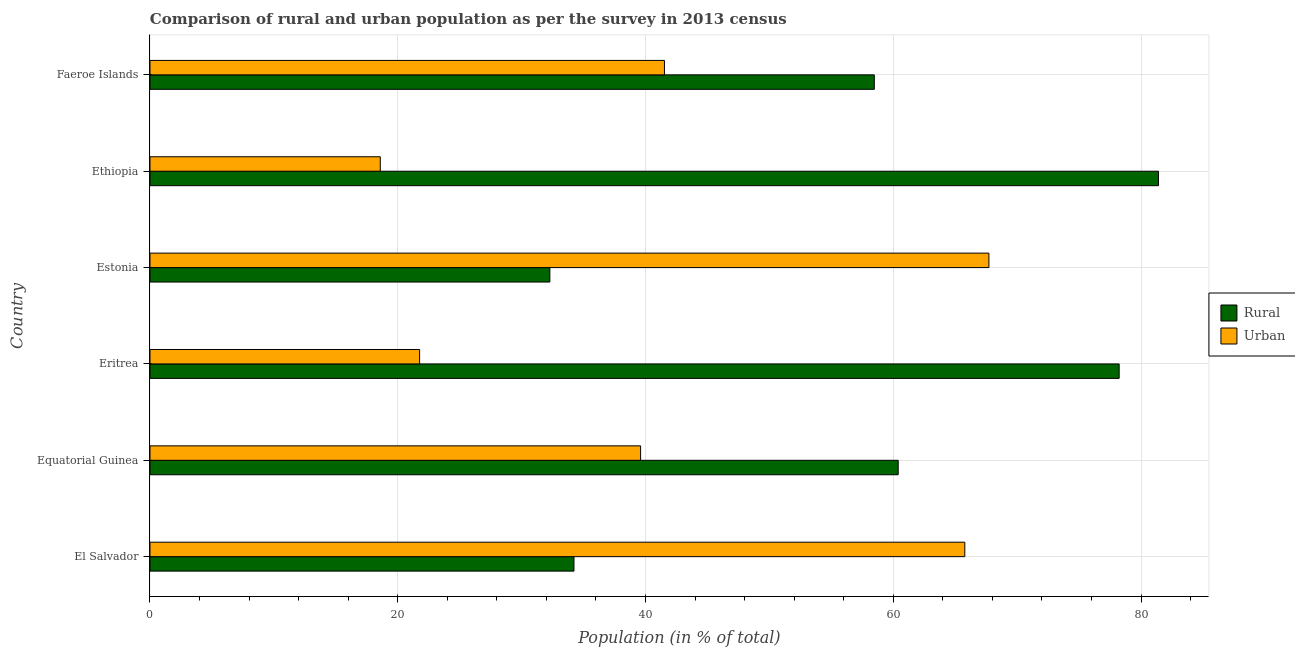How many different coloured bars are there?
Your answer should be compact. 2. How many bars are there on the 3rd tick from the bottom?
Offer a terse response. 2. What is the label of the 4th group of bars from the top?
Your answer should be very brief. Eritrea. In how many cases, is the number of bars for a given country not equal to the number of legend labels?
Provide a succinct answer. 0. What is the urban population in Faeroe Islands?
Offer a terse response. 41.53. Across all countries, what is the maximum urban population?
Your response must be concise. 67.72. Across all countries, what is the minimum urban population?
Provide a short and direct response. 18.59. In which country was the urban population maximum?
Give a very brief answer. Estonia. In which country was the rural population minimum?
Ensure brevity in your answer.  Estonia. What is the total urban population in the graph?
Ensure brevity in your answer.  254.98. What is the difference between the urban population in Ethiopia and that in Faeroe Islands?
Provide a succinct answer. -22.94. What is the difference between the rural population in Equatorial Guinea and the urban population in Ethiopia?
Provide a succinct answer. 41.81. What is the average rural population per country?
Provide a short and direct response. 57.5. What is the difference between the urban population and rural population in Equatorial Guinea?
Make the answer very short. -20.79. What is the ratio of the urban population in Equatorial Guinea to that in Ethiopia?
Your answer should be compact. 2.13. Is the urban population in Equatorial Guinea less than that in Ethiopia?
Offer a terse response. No. What is the difference between the highest and the second highest urban population?
Offer a terse response. 1.95. What is the difference between the highest and the lowest rural population?
Provide a succinct answer. 49.13. Is the sum of the rural population in El Salvador and Estonia greater than the maximum urban population across all countries?
Your response must be concise. No. What does the 2nd bar from the top in Faeroe Islands represents?
Make the answer very short. Rural. What does the 1st bar from the bottom in Equatorial Guinea represents?
Give a very brief answer. Rural. How many bars are there?
Your response must be concise. 12. How many countries are there in the graph?
Make the answer very short. 6. Are the values on the major ticks of X-axis written in scientific E-notation?
Your response must be concise. No. Does the graph contain grids?
Keep it short and to the point. Yes. Where does the legend appear in the graph?
Ensure brevity in your answer.  Center right. How many legend labels are there?
Offer a terse response. 2. What is the title of the graph?
Make the answer very short. Comparison of rural and urban population as per the survey in 2013 census. What is the label or title of the X-axis?
Make the answer very short. Population (in % of total). What is the Population (in % of total) in Rural in El Salvador?
Ensure brevity in your answer.  34.23. What is the Population (in % of total) in Urban in El Salvador?
Your answer should be very brief. 65.78. What is the Population (in % of total) of Rural in Equatorial Guinea?
Your response must be concise. 60.4. What is the Population (in % of total) in Urban in Equatorial Guinea?
Provide a succinct answer. 39.6. What is the Population (in % of total) in Rural in Eritrea?
Your answer should be compact. 78.23. What is the Population (in % of total) of Urban in Eritrea?
Offer a very short reply. 21.77. What is the Population (in % of total) of Rural in Estonia?
Keep it short and to the point. 32.28. What is the Population (in % of total) in Urban in Estonia?
Give a very brief answer. 67.72. What is the Population (in % of total) in Rural in Ethiopia?
Give a very brief answer. 81.41. What is the Population (in % of total) in Urban in Ethiopia?
Provide a short and direct response. 18.59. What is the Population (in % of total) in Rural in Faeroe Islands?
Give a very brief answer. 58.47. What is the Population (in % of total) of Urban in Faeroe Islands?
Your answer should be compact. 41.53. Across all countries, what is the maximum Population (in % of total) of Rural?
Keep it short and to the point. 81.41. Across all countries, what is the maximum Population (in % of total) in Urban?
Provide a succinct answer. 67.72. Across all countries, what is the minimum Population (in % of total) of Rural?
Make the answer very short. 32.28. Across all countries, what is the minimum Population (in % of total) in Urban?
Make the answer very short. 18.59. What is the total Population (in % of total) in Rural in the graph?
Make the answer very short. 345.02. What is the total Population (in % of total) in Urban in the graph?
Ensure brevity in your answer.  254.98. What is the difference between the Population (in % of total) of Rural in El Salvador and that in Equatorial Guinea?
Offer a terse response. -26.17. What is the difference between the Population (in % of total) in Urban in El Salvador and that in Equatorial Guinea?
Keep it short and to the point. 26.17. What is the difference between the Population (in % of total) in Rural in El Salvador and that in Eritrea?
Provide a short and direct response. -44.01. What is the difference between the Population (in % of total) of Urban in El Salvador and that in Eritrea?
Make the answer very short. 44.01. What is the difference between the Population (in % of total) in Rural in El Salvador and that in Estonia?
Offer a terse response. 1.95. What is the difference between the Population (in % of total) in Urban in El Salvador and that in Estonia?
Give a very brief answer. -1.95. What is the difference between the Population (in % of total) of Rural in El Salvador and that in Ethiopia?
Provide a short and direct response. -47.19. What is the difference between the Population (in % of total) in Urban in El Salvador and that in Ethiopia?
Provide a short and direct response. 47.19. What is the difference between the Population (in % of total) of Rural in El Salvador and that in Faeroe Islands?
Your response must be concise. -24.25. What is the difference between the Population (in % of total) in Urban in El Salvador and that in Faeroe Islands?
Your answer should be very brief. 24.25. What is the difference between the Population (in % of total) in Rural in Equatorial Guinea and that in Eritrea?
Your answer should be compact. -17.84. What is the difference between the Population (in % of total) of Urban in Equatorial Guinea and that in Eritrea?
Provide a succinct answer. 17.84. What is the difference between the Population (in % of total) in Rural in Equatorial Guinea and that in Estonia?
Provide a succinct answer. 28.12. What is the difference between the Population (in % of total) of Urban in Equatorial Guinea and that in Estonia?
Your answer should be very brief. -28.12. What is the difference between the Population (in % of total) in Rural in Equatorial Guinea and that in Ethiopia?
Ensure brevity in your answer.  -21.01. What is the difference between the Population (in % of total) of Urban in Equatorial Guinea and that in Ethiopia?
Offer a very short reply. 21.01. What is the difference between the Population (in % of total) in Rural in Equatorial Guinea and that in Faeroe Islands?
Offer a very short reply. 1.93. What is the difference between the Population (in % of total) in Urban in Equatorial Guinea and that in Faeroe Islands?
Offer a very short reply. -1.93. What is the difference between the Population (in % of total) of Rural in Eritrea and that in Estonia?
Provide a succinct answer. 45.96. What is the difference between the Population (in % of total) of Urban in Eritrea and that in Estonia?
Make the answer very short. -45.96. What is the difference between the Population (in % of total) of Rural in Eritrea and that in Ethiopia?
Your response must be concise. -3.17. What is the difference between the Population (in % of total) in Urban in Eritrea and that in Ethiopia?
Your response must be concise. 3.17. What is the difference between the Population (in % of total) of Rural in Eritrea and that in Faeroe Islands?
Provide a short and direct response. 19.77. What is the difference between the Population (in % of total) in Urban in Eritrea and that in Faeroe Islands?
Keep it short and to the point. -19.77. What is the difference between the Population (in % of total) of Rural in Estonia and that in Ethiopia?
Offer a very short reply. -49.13. What is the difference between the Population (in % of total) in Urban in Estonia and that in Ethiopia?
Ensure brevity in your answer.  49.13. What is the difference between the Population (in % of total) of Rural in Estonia and that in Faeroe Islands?
Make the answer very short. -26.19. What is the difference between the Population (in % of total) in Urban in Estonia and that in Faeroe Islands?
Ensure brevity in your answer.  26.19. What is the difference between the Population (in % of total) in Rural in Ethiopia and that in Faeroe Islands?
Provide a succinct answer. 22.94. What is the difference between the Population (in % of total) of Urban in Ethiopia and that in Faeroe Islands?
Your response must be concise. -22.94. What is the difference between the Population (in % of total) of Rural in El Salvador and the Population (in % of total) of Urban in Equatorial Guinea?
Your response must be concise. -5.38. What is the difference between the Population (in % of total) of Rural in El Salvador and the Population (in % of total) of Urban in Eritrea?
Provide a short and direct response. 12.46. What is the difference between the Population (in % of total) of Rural in El Salvador and the Population (in % of total) of Urban in Estonia?
Offer a terse response. -33.5. What is the difference between the Population (in % of total) in Rural in El Salvador and the Population (in % of total) in Urban in Ethiopia?
Your response must be concise. 15.63. What is the difference between the Population (in % of total) of Rural in El Salvador and the Population (in % of total) of Urban in Faeroe Islands?
Provide a short and direct response. -7.3. What is the difference between the Population (in % of total) of Rural in Equatorial Guinea and the Population (in % of total) of Urban in Eritrea?
Your answer should be very brief. 38.63. What is the difference between the Population (in % of total) of Rural in Equatorial Guinea and the Population (in % of total) of Urban in Estonia?
Your response must be concise. -7.32. What is the difference between the Population (in % of total) of Rural in Equatorial Guinea and the Population (in % of total) of Urban in Ethiopia?
Your answer should be compact. 41.81. What is the difference between the Population (in % of total) in Rural in Equatorial Guinea and the Population (in % of total) in Urban in Faeroe Islands?
Keep it short and to the point. 18.87. What is the difference between the Population (in % of total) of Rural in Eritrea and the Population (in % of total) of Urban in Estonia?
Your answer should be very brief. 10.51. What is the difference between the Population (in % of total) of Rural in Eritrea and the Population (in % of total) of Urban in Ethiopia?
Offer a very short reply. 59.65. What is the difference between the Population (in % of total) of Rural in Eritrea and the Population (in % of total) of Urban in Faeroe Islands?
Keep it short and to the point. 36.7. What is the difference between the Population (in % of total) in Rural in Estonia and the Population (in % of total) in Urban in Ethiopia?
Provide a succinct answer. 13.69. What is the difference between the Population (in % of total) in Rural in Estonia and the Population (in % of total) in Urban in Faeroe Islands?
Your response must be concise. -9.25. What is the difference between the Population (in % of total) in Rural in Ethiopia and the Population (in % of total) in Urban in Faeroe Islands?
Provide a succinct answer. 39.88. What is the average Population (in % of total) of Rural per country?
Offer a very short reply. 57.5. What is the average Population (in % of total) in Urban per country?
Keep it short and to the point. 42.5. What is the difference between the Population (in % of total) of Rural and Population (in % of total) of Urban in El Salvador?
Your response must be concise. -31.55. What is the difference between the Population (in % of total) in Rural and Population (in % of total) in Urban in Equatorial Guinea?
Provide a short and direct response. 20.79. What is the difference between the Population (in % of total) of Rural and Population (in % of total) of Urban in Eritrea?
Provide a succinct answer. 56.47. What is the difference between the Population (in % of total) of Rural and Population (in % of total) of Urban in Estonia?
Give a very brief answer. -35.44. What is the difference between the Population (in % of total) of Rural and Population (in % of total) of Urban in Ethiopia?
Offer a very short reply. 62.82. What is the difference between the Population (in % of total) of Rural and Population (in % of total) of Urban in Faeroe Islands?
Make the answer very short. 16.94. What is the ratio of the Population (in % of total) of Rural in El Salvador to that in Equatorial Guinea?
Offer a terse response. 0.57. What is the ratio of the Population (in % of total) of Urban in El Salvador to that in Equatorial Guinea?
Offer a terse response. 1.66. What is the ratio of the Population (in % of total) of Rural in El Salvador to that in Eritrea?
Give a very brief answer. 0.44. What is the ratio of the Population (in % of total) in Urban in El Salvador to that in Eritrea?
Offer a very short reply. 3.02. What is the ratio of the Population (in % of total) of Rural in El Salvador to that in Estonia?
Your response must be concise. 1.06. What is the ratio of the Population (in % of total) of Urban in El Salvador to that in Estonia?
Your response must be concise. 0.97. What is the ratio of the Population (in % of total) of Rural in El Salvador to that in Ethiopia?
Offer a terse response. 0.42. What is the ratio of the Population (in % of total) of Urban in El Salvador to that in Ethiopia?
Ensure brevity in your answer.  3.54. What is the ratio of the Population (in % of total) in Rural in El Salvador to that in Faeroe Islands?
Keep it short and to the point. 0.59. What is the ratio of the Population (in % of total) of Urban in El Salvador to that in Faeroe Islands?
Your response must be concise. 1.58. What is the ratio of the Population (in % of total) in Rural in Equatorial Guinea to that in Eritrea?
Give a very brief answer. 0.77. What is the ratio of the Population (in % of total) of Urban in Equatorial Guinea to that in Eritrea?
Offer a terse response. 1.82. What is the ratio of the Population (in % of total) of Rural in Equatorial Guinea to that in Estonia?
Provide a short and direct response. 1.87. What is the ratio of the Population (in % of total) of Urban in Equatorial Guinea to that in Estonia?
Provide a short and direct response. 0.58. What is the ratio of the Population (in % of total) in Rural in Equatorial Guinea to that in Ethiopia?
Keep it short and to the point. 0.74. What is the ratio of the Population (in % of total) in Urban in Equatorial Guinea to that in Ethiopia?
Offer a terse response. 2.13. What is the ratio of the Population (in % of total) of Rural in Equatorial Guinea to that in Faeroe Islands?
Keep it short and to the point. 1.03. What is the ratio of the Population (in % of total) in Urban in Equatorial Guinea to that in Faeroe Islands?
Give a very brief answer. 0.95. What is the ratio of the Population (in % of total) of Rural in Eritrea to that in Estonia?
Ensure brevity in your answer.  2.42. What is the ratio of the Population (in % of total) in Urban in Eritrea to that in Estonia?
Offer a terse response. 0.32. What is the ratio of the Population (in % of total) of Urban in Eritrea to that in Ethiopia?
Keep it short and to the point. 1.17. What is the ratio of the Population (in % of total) in Rural in Eritrea to that in Faeroe Islands?
Provide a succinct answer. 1.34. What is the ratio of the Population (in % of total) in Urban in Eritrea to that in Faeroe Islands?
Provide a succinct answer. 0.52. What is the ratio of the Population (in % of total) in Rural in Estonia to that in Ethiopia?
Offer a terse response. 0.4. What is the ratio of the Population (in % of total) in Urban in Estonia to that in Ethiopia?
Offer a very short reply. 3.64. What is the ratio of the Population (in % of total) of Rural in Estonia to that in Faeroe Islands?
Offer a very short reply. 0.55. What is the ratio of the Population (in % of total) in Urban in Estonia to that in Faeroe Islands?
Provide a succinct answer. 1.63. What is the ratio of the Population (in % of total) in Rural in Ethiopia to that in Faeroe Islands?
Keep it short and to the point. 1.39. What is the ratio of the Population (in % of total) of Urban in Ethiopia to that in Faeroe Islands?
Provide a succinct answer. 0.45. What is the difference between the highest and the second highest Population (in % of total) in Rural?
Offer a very short reply. 3.17. What is the difference between the highest and the second highest Population (in % of total) in Urban?
Your answer should be very brief. 1.95. What is the difference between the highest and the lowest Population (in % of total) of Rural?
Keep it short and to the point. 49.13. What is the difference between the highest and the lowest Population (in % of total) of Urban?
Offer a very short reply. 49.13. 